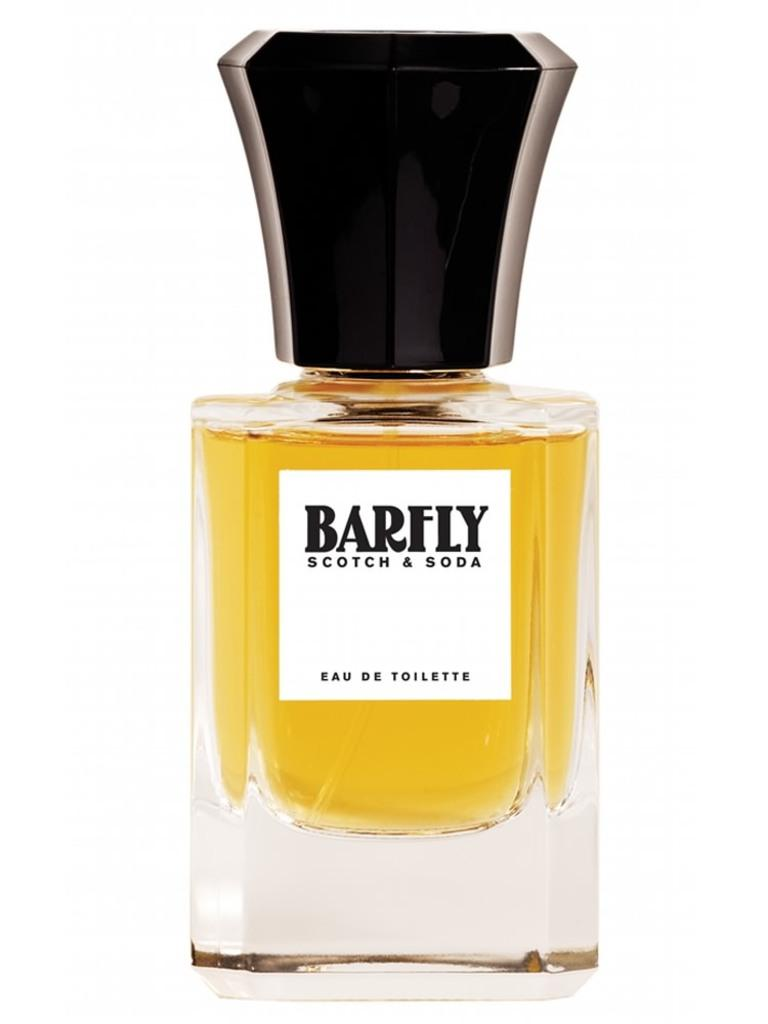Provide a one-sentence caption for the provided image. A bottle of Barfly Scotch & Soda perfume on display over a white background. 